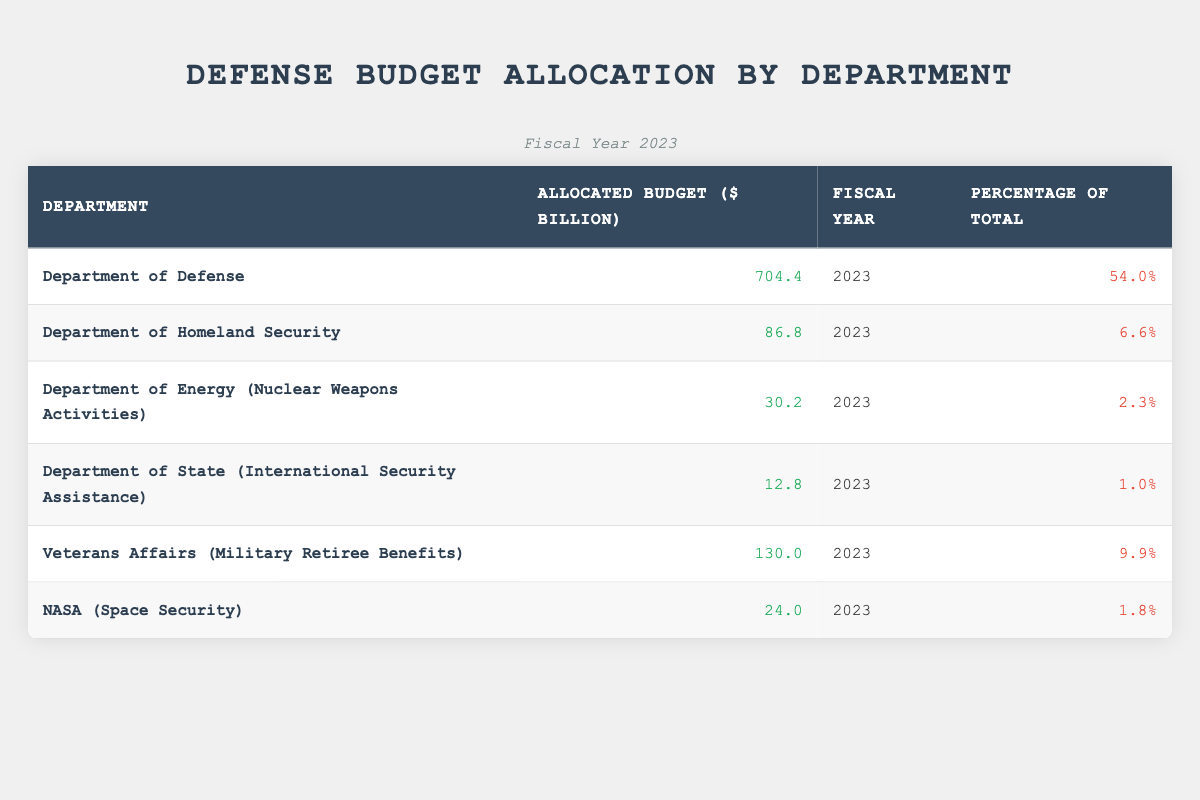What is the allocated budget for the Department of Defense? The table shows that the allocated budget for the Department of Defense is listed directly under the "Allocated Budget" column for that department. According to the table, it is 704.4 billion dollars.
Answer: 704.4 billion dollars Which department has the smallest budget allocation? To find the department with the smallest budget allocation, we compare the values in the "Allocated Budget" column. The smallest value is 12.8 billion dollars, which corresponds to the Department of State (International Security Assistance).
Answer: Department of State (International Security Assistance) What is the total allocated budget for all departments listed? To find the total allocated budget, we sum the allocated budgets of all departments in the "Allocated Budget" column: 704.4 + 86.8 + 30.2 + 12.8 + 130.0 + 24.0 = 988.2 billion dollars.
Answer: 988.2 billion dollars Is the allocated budget for Veterans Affairs greater than the combined allocations of NASA and the Department of State? First, we find the budget for Veterans Affairs, which is 130.0 billion dollars. Then we sum the allocations for NASA (24.0 billion dollars) and the Department of State (12.8 billion dollars): 24.0 + 12.8 = 36.8 billion dollars. Since 130.0 is greater than 36.8, the answer is yes.
Answer: Yes What percentage of the total budget allocation is designated for the Department of Homeland Security? The table includes a specific percentage for each department in the "Percentage of Total" column. The Department of Homeland Security has been allocated 6.6% of the total budget.
Answer: 6.6% How much of the total budget is allocated to departments other than the Department of Defense? We first need to find the budget for the Department of Defense, which is 704.4 billion dollars, and subtract it from the total allocated budget (988.2 billion dollars). This results in 988.2 - 704.4 = 283.8 billion dollars allocated to the other departments.
Answer: 283.8 billion dollars Which department accounts for more than 5% of the total budget allocation? We look at the "Percentage of Total" column and see which departments have percentages greater than 5%. Only the Department of Defense, with 54%, and the Department of Homeland Security, with 6.6%, meet this criterion.
Answer: Department of Defense, Department of Homeland Security What is the average allocated budget across all departments listed? To find the average, we take the total allocated budget (988.2 billion dollars) and divide it by the number of departments, which is 6. Therefore, the average is 988.2 / 6 = 164.7 billion dollars.
Answer: 164.7 billion dollars How many departments have an allocation of less than 10 billion dollars? By checking the "Allocated Budget" column for values less than 10 billion dollars, we see that departments with allocations of 12.8, 24.0, 30.2, 86.8, and 704.4 billion dollars do not fall below this threshold; hence, no departments meet the requirement.
Answer: None 